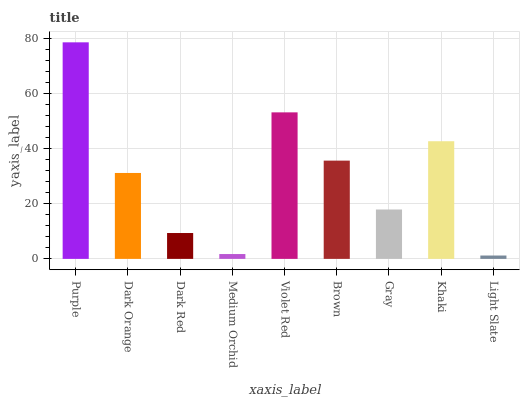Is Light Slate the minimum?
Answer yes or no. Yes. Is Purple the maximum?
Answer yes or no. Yes. Is Dark Orange the minimum?
Answer yes or no. No. Is Dark Orange the maximum?
Answer yes or no. No. Is Purple greater than Dark Orange?
Answer yes or no. Yes. Is Dark Orange less than Purple?
Answer yes or no. Yes. Is Dark Orange greater than Purple?
Answer yes or no. No. Is Purple less than Dark Orange?
Answer yes or no. No. Is Dark Orange the high median?
Answer yes or no. Yes. Is Dark Orange the low median?
Answer yes or no. Yes. Is Purple the high median?
Answer yes or no. No. Is Violet Red the low median?
Answer yes or no. No. 